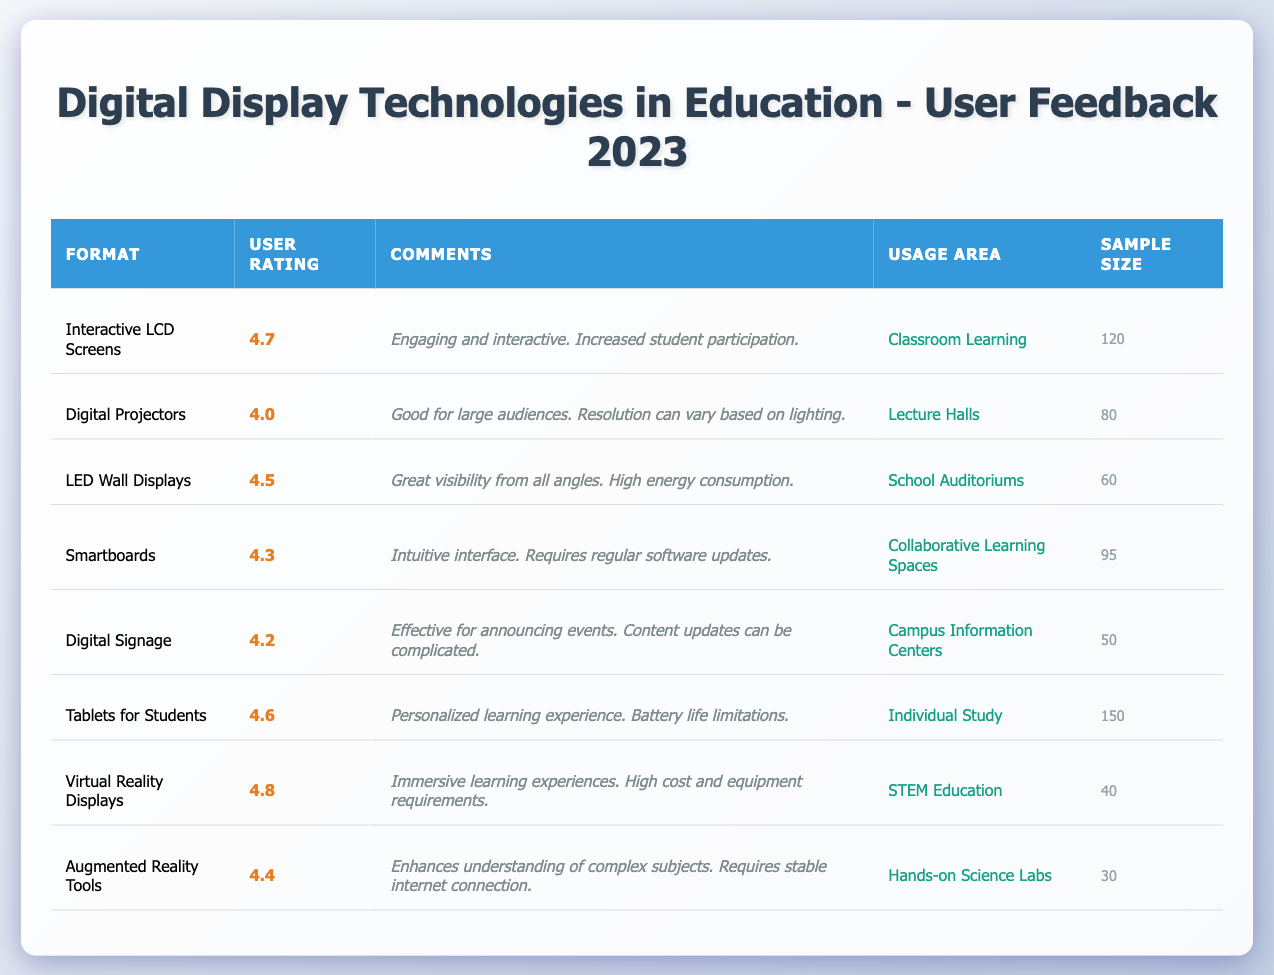What is the user rating for Virtual Reality Displays? The user rating for Virtual Reality Displays can be found in the second column of the respective row, which shows a rating of 4.8.
Answer: 4.8 Which digital display format has the highest user rating? By comparing the ratings in the table, Virtual Reality Displays have the highest rating at 4.8, more than any other formats listed.
Answer: Virtual Reality Displays How many users rated Digital Projectors? The sample size for Digital Projectors is provided in the last column of their respective row, which indicates that 80 users rated it.
Answer: 80 What is the average user rating of all the formats listed? To find the average, add all the ratings (4.7 + 4.0 + 4.5 + 4.3 + 4.2 + 4.6 + 4.8 + 4.4 = 36.5) and divide by the number of formats (8). So, the average rating is 36.5 / 8 = 4.5625.
Answer: 4.56 Which usage area has the lowest rated format? The lowest rating is for Digital Projectors with a user rating of 4.0, which is associated with Lecture Halls. This is found by looking at the ratings in relation to the usage areas.
Answer: Lecture Halls Does any display format have comments about high energy consumption? Yes, the LED Wall Displays have a comment stating, "High energy consumption," indicating that this is a concern for that format.
Answer: Yes Which format indicates a need for stable internet connection? According to the comments for Augmented Reality Tools, it mentions a requirement for a stable internet connection. This information is found in the comments section of that specific row.
Answer: Augmented Reality Tools Are there more users that rated Tablets for Students or Virtual Reality Displays? Tablets for Students have a sample size of 150 while Virtual Reality Displays have 40. Thus, Tablets for Students have a larger sample size indicating more users rated this format.
Answer: Tablets for Students What is the difference in user ratings between Interactive LCD Screens and Smartboards? Interactive LCD Screens have a rating of 4.7 while Smartboards have a rating of 4.3. The difference is 4.7 - 4.3 = 0.4.
Answer: 0.4 How many total users rated all the formats combined? Adding the sample sizes for all formats: 120 + 80 + 60 + 95 + 50 + 150 + 40 + 30 = 625. This provides the total number of users who rated the formats.
Answer: 625 